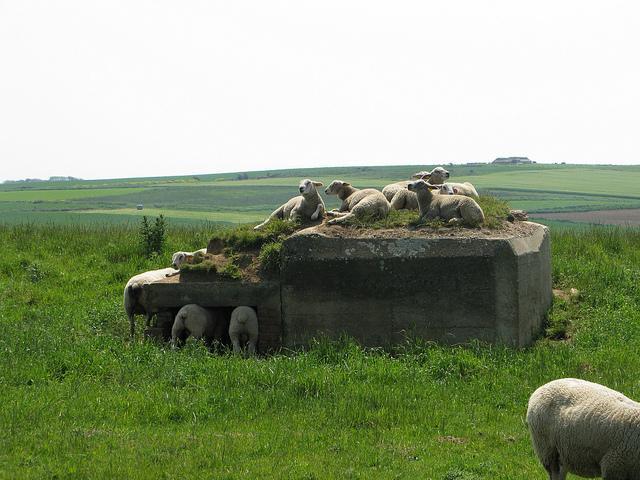How many sheep can be seen?
Give a very brief answer. 2. 